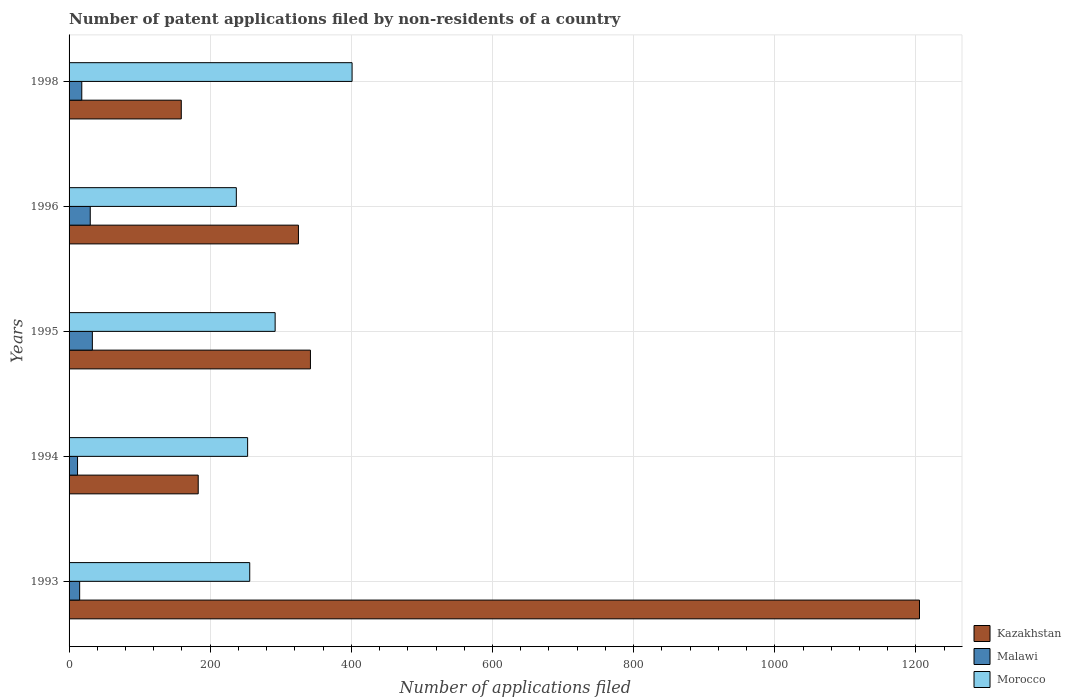Are the number of bars per tick equal to the number of legend labels?
Your answer should be compact. Yes. Are the number of bars on each tick of the Y-axis equal?
Offer a terse response. Yes. How many bars are there on the 4th tick from the top?
Make the answer very short. 3. How many bars are there on the 3rd tick from the bottom?
Give a very brief answer. 3. In how many cases, is the number of bars for a given year not equal to the number of legend labels?
Provide a short and direct response. 0. What is the number of applications filed in Morocco in 1993?
Provide a short and direct response. 256. Across all years, what is the maximum number of applications filed in Morocco?
Provide a succinct answer. 401. Across all years, what is the minimum number of applications filed in Malawi?
Your response must be concise. 12. What is the total number of applications filed in Morocco in the graph?
Give a very brief answer. 1439. What is the difference between the number of applications filed in Morocco in 1995 and that in 1998?
Your answer should be very brief. -109. What is the difference between the number of applications filed in Malawi in 1994 and the number of applications filed in Kazakhstan in 1996?
Provide a short and direct response. -313. What is the average number of applications filed in Malawi per year?
Provide a succinct answer. 21.6. What is the ratio of the number of applications filed in Malawi in 1995 to that in 1996?
Your answer should be compact. 1.1. What is the difference between the highest and the second highest number of applications filed in Morocco?
Ensure brevity in your answer.  109. What is the difference between the highest and the lowest number of applications filed in Kazakhstan?
Give a very brief answer. 1046. Is the sum of the number of applications filed in Kazakhstan in 1995 and 1996 greater than the maximum number of applications filed in Morocco across all years?
Offer a terse response. Yes. What does the 1st bar from the top in 1994 represents?
Provide a short and direct response. Morocco. What does the 3rd bar from the bottom in 1994 represents?
Give a very brief answer. Morocco. Are all the bars in the graph horizontal?
Offer a terse response. Yes. How many years are there in the graph?
Keep it short and to the point. 5. What is the difference between two consecutive major ticks on the X-axis?
Your response must be concise. 200. Does the graph contain grids?
Offer a terse response. Yes. How are the legend labels stacked?
Your answer should be very brief. Vertical. What is the title of the graph?
Offer a terse response. Number of patent applications filed by non-residents of a country. What is the label or title of the X-axis?
Provide a short and direct response. Number of applications filed. What is the label or title of the Y-axis?
Your answer should be compact. Years. What is the Number of applications filed in Kazakhstan in 1993?
Provide a succinct answer. 1205. What is the Number of applications filed in Malawi in 1993?
Give a very brief answer. 15. What is the Number of applications filed in Morocco in 1993?
Make the answer very short. 256. What is the Number of applications filed of Kazakhstan in 1994?
Offer a terse response. 183. What is the Number of applications filed of Morocco in 1994?
Your answer should be compact. 253. What is the Number of applications filed of Kazakhstan in 1995?
Give a very brief answer. 342. What is the Number of applications filed of Malawi in 1995?
Ensure brevity in your answer.  33. What is the Number of applications filed in Morocco in 1995?
Provide a succinct answer. 292. What is the Number of applications filed of Kazakhstan in 1996?
Ensure brevity in your answer.  325. What is the Number of applications filed in Malawi in 1996?
Your response must be concise. 30. What is the Number of applications filed in Morocco in 1996?
Your answer should be compact. 237. What is the Number of applications filed of Kazakhstan in 1998?
Provide a short and direct response. 159. What is the Number of applications filed in Morocco in 1998?
Your response must be concise. 401. Across all years, what is the maximum Number of applications filed in Kazakhstan?
Your answer should be compact. 1205. Across all years, what is the maximum Number of applications filed in Malawi?
Ensure brevity in your answer.  33. Across all years, what is the maximum Number of applications filed in Morocco?
Offer a terse response. 401. Across all years, what is the minimum Number of applications filed in Kazakhstan?
Make the answer very short. 159. Across all years, what is the minimum Number of applications filed of Malawi?
Provide a succinct answer. 12. Across all years, what is the minimum Number of applications filed of Morocco?
Provide a short and direct response. 237. What is the total Number of applications filed in Kazakhstan in the graph?
Provide a succinct answer. 2214. What is the total Number of applications filed in Malawi in the graph?
Make the answer very short. 108. What is the total Number of applications filed of Morocco in the graph?
Keep it short and to the point. 1439. What is the difference between the Number of applications filed of Kazakhstan in 1993 and that in 1994?
Provide a succinct answer. 1022. What is the difference between the Number of applications filed in Morocco in 1993 and that in 1994?
Your answer should be very brief. 3. What is the difference between the Number of applications filed in Kazakhstan in 1993 and that in 1995?
Make the answer very short. 863. What is the difference between the Number of applications filed of Morocco in 1993 and that in 1995?
Your answer should be compact. -36. What is the difference between the Number of applications filed in Kazakhstan in 1993 and that in 1996?
Give a very brief answer. 880. What is the difference between the Number of applications filed of Morocco in 1993 and that in 1996?
Keep it short and to the point. 19. What is the difference between the Number of applications filed of Kazakhstan in 1993 and that in 1998?
Provide a short and direct response. 1046. What is the difference between the Number of applications filed in Malawi in 1993 and that in 1998?
Your response must be concise. -3. What is the difference between the Number of applications filed in Morocco in 1993 and that in 1998?
Make the answer very short. -145. What is the difference between the Number of applications filed in Kazakhstan in 1994 and that in 1995?
Your answer should be compact. -159. What is the difference between the Number of applications filed of Morocco in 1994 and that in 1995?
Offer a terse response. -39. What is the difference between the Number of applications filed in Kazakhstan in 1994 and that in 1996?
Your answer should be very brief. -142. What is the difference between the Number of applications filed in Malawi in 1994 and that in 1996?
Make the answer very short. -18. What is the difference between the Number of applications filed of Kazakhstan in 1994 and that in 1998?
Your response must be concise. 24. What is the difference between the Number of applications filed of Malawi in 1994 and that in 1998?
Offer a very short reply. -6. What is the difference between the Number of applications filed in Morocco in 1994 and that in 1998?
Offer a terse response. -148. What is the difference between the Number of applications filed in Morocco in 1995 and that in 1996?
Keep it short and to the point. 55. What is the difference between the Number of applications filed in Kazakhstan in 1995 and that in 1998?
Offer a very short reply. 183. What is the difference between the Number of applications filed in Morocco in 1995 and that in 1998?
Your response must be concise. -109. What is the difference between the Number of applications filed of Kazakhstan in 1996 and that in 1998?
Keep it short and to the point. 166. What is the difference between the Number of applications filed of Malawi in 1996 and that in 1998?
Ensure brevity in your answer.  12. What is the difference between the Number of applications filed of Morocco in 1996 and that in 1998?
Ensure brevity in your answer.  -164. What is the difference between the Number of applications filed of Kazakhstan in 1993 and the Number of applications filed of Malawi in 1994?
Your response must be concise. 1193. What is the difference between the Number of applications filed in Kazakhstan in 1993 and the Number of applications filed in Morocco in 1994?
Ensure brevity in your answer.  952. What is the difference between the Number of applications filed in Malawi in 1993 and the Number of applications filed in Morocco in 1994?
Your response must be concise. -238. What is the difference between the Number of applications filed of Kazakhstan in 1993 and the Number of applications filed of Malawi in 1995?
Provide a succinct answer. 1172. What is the difference between the Number of applications filed in Kazakhstan in 1993 and the Number of applications filed in Morocco in 1995?
Provide a short and direct response. 913. What is the difference between the Number of applications filed in Malawi in 1993 and the Number of applications filed in Morocco in 1995?
Make the answer very short. -277. What is the difference between the Number of applications filed in Kazakhstan in 1993 and the Number of applications filed in Malawi in 1996?
Make the answer very short. 1175. What is the difference between the Number of applications filed in Kazakhstan in 1993 and the Number of applications filed in Morocco in 1996?
Make the answer very short. 968. What is the difference between the Number of applications filed in Malawi in 1993 and the Number of applications filed in Morocco in 1996?
Provide a short and direct response. -222. What is the difference between the Number of applications filed in Kazakhstan in 1993 and the Number of applications filed in Malawi in 1998?
Your answer should be very brief. 1187. What is the difference between the Number of applications filed in Kazakhstan in 1993 and the Number of applications filed in Morocco in 1998?
Offer a terse response. 804. What is the difference between the Number of applications filed in Malawi in 1993 and the Number of applications filed in Morocco in 1998?
Your answer should be very brief. -386. What is the difference between the Number of applications filed in Kazakhstan in 1994 and the Number of applications filed in Malawi in 1995?
Make the answer very short. 150. What is the difference between the Number of applications filed in Kazakhstan in 1994 and the Number of applications filed in Morocco in 1995?
Provide a short and direct response. -109. What is the difference between the Number of applications filed of Malawi in 1994 and the Number of applications filed of Morocco in 1995?
Your answer should be compact. -280. What is the difference between the Number of applications filed of Kazakhstan in 1994 and the Number of applications filed of Malawi in 1996?
Provide a succinct answer. 153. What is the difference between the Number of applications filed in Kazakhstan in 1994 and the Number of applications filed in Morocco in 1996?
Make the answer very short. -54. What is the difference between the Number of applications filed of Malawi in 1994 and the Number of applications filed of Morocco in 1996?
Offer a very short reply. -225. What is the difference between the Number of applications filed in Kazakhstan in 1994 and the Number of applications filed in Malawi in 1998?
Your answer should be very brief. 165. What is the difference between the Number of applications filed in Kazakhstan in 1994 and the Number of applications filed in Morocco in 1998?
Your answer should be very brief. -218. What is the difference between the Number of applications filed in Malawi in 1994 and the Number of applications filed in Morocco in 1998?
Your response must be concise. -389. What is the difference between the Number of applications filed of Kazakhstan in 1995 and the Number of applications filed of Malawi in 1996?
Provide a short and direct response. 312. What is the difference between the Number of applications filed of Kazakhstan in 1995 and the Number of applications filed of Morocco in 1996?
Provide a succinct answer. 105. What is the difference between the Number of applications filed of Malawi in 1995 and the Number of applications filed of Morocco in 1996?
Your answer should be very brief. -204. What is the difference between the Number of applications filed in Kazakhstan in 1995 and the Number of applications filed in Malawi in 1998?
Offer a very short reply. 324. What is the difference between the Number of applications filed of Kazakhstan in 1995 and the Number of applications filed of Morocco in 1998?
Provide a short and direct response. -59. What is the difference between the Number of applications filed in Malawi in 1995 and the Number of applications filed in Morocco in 1998?
Offer a very short reply. -368. What is the difference between the Number of applications filed in Kazakhstan in 1996 and the Number of applications filed in Malawi in 1998?
Make the answer very short. 307. What is the difference between the Number of applications filed in Kazakhstan in 1996 and the Number of applications filed in Morocco in 1998?
Give a very brief answer. -76. What is the difference between the Number of applications filed of Malawi in 1996 and the Number of applications filed of Morocco in 1998?
Your answer should be very brief. -371. What is the average Number of applications filed in Kazakhstan per year?
Ensure brevity in your answer.  442.8. What is the average Number of applications filed in Malawi per year?
Your answer should be very brief. 21.6. What is the average Number of applications filed in Morocco per year?
Your response must be concise. 287.8. In the year 1993, what is the difference between the Number of applications filed of Kazakhstan and Number of applications filed of Malawi?
Your answer should be very brief. 1190. In the year 1993, what is the difference between the Number of applications filed of Kazakhstan and Number of applications filed of Morocco?
Give a very brief answer. 949. In the year 1993, what is the difference between the Number of applications filed in Malawi and Number of applications filed in Morocco?
Keep it short and to the point. -241. In the year 1994, what is the difference between the Number of applications filed in Kazakhstan and Number of applications filed in Malawi?
Make the answer very short. 171. In the year 1994, what is the difference between the Number of applications filed in Kazakhstan and Number of applications filed in Morocco?
Provide a short and direct response. -70. In the year 1994, what is the difference between the Number of applications filed of Malawi and Number of applications filed of Morocco?
Your response must be concise. -241. In the year 1995, what is the difference between the Number of applications filed in Kazakhstan and Number of applications filed in Malawi?
Your answer should be compact. 309. In the year 1995, what is the difference between the Number of applications filed of Kazakhstan and Number of applications filed of Morocco?
Keep it short and to the point. 50. In the year 1995, what is the difference between the Number of applications filed of Malawi and Number of applications filed of Morocco?
Provide a short and direct response. -259. In the year 1996, what is the difference between the Number of applications filed of Kazakhstan and Number of applications filed of Malawi?
Provide a short and direct response. 295. In the year 1996, what is the difference between the Number of applications filed in Kazakhstan and Number of applications filed in Morocco?
Provide a succinct answer. 88. In the year 1996, what is the difference between the Number of applications filed of Malawi and Number of applications filed of Morocco?
Your response must be concise. -207. In the year 1998, what is the difference between the Number of applications filed of Kazakhstan and Number of applications filed of Malawi?
Give a very brief answer. 141. In the year 1998, what is the difference between the Number of applications filed in Kazakhstan and Number of applications filed in Morocco?
Give a very brief answer. -242. In the year 1998, what is the difference between the Number of applications filed of Malawi and Number of applications filed of Morocco?
Give a very brief answer. -383. What is the ratio of the Number of applications filed of Kazakhstan in 1993 to that in 1994?
Your answer should be compact. 6.58. What is the ratio of the Number of applications filed of Morocco in 1993 to that in 1994?
Keep it short and to the point. 1.01. What is the ratio of the Number of applications filed of Kazakhstan in 1993 to that in 1995?
Offer a very short reply. 3.52. What is the ratio of the Number of applications filed in Malawi in 1993 to that in 1995?
Offer a very short reply. 0.45. What is the ratio of the Number of applications filed of Morocco in 1993 to that in 1995?
Provide a succinct answer. 0.88. What is the ratio of the Number of applications filed of Kazakhstan in 1993 to that in 1996?
Provide a succinct answer. 3.71. What is the ratio of the Number of applications filed in Malawi in 1993 to that in 1996?
Offer a terse response. 0.5. What is the ratio of the Number of applications filed of Morocco in 1993 to that in 1996?
Give a very brief answer. 1.08. What is the ratio of the Number of applications filed in Kazakhstan in 1993 to that in 1998?
Make the answer very short. 7.58. What is the ratio of the Number of applications filed in Malawi in 1993 to that in 1998?
Your answer should be compact. 0.83. What is the ratio of the Number of applications filed of Morocco in 1993 to that in 1998?
Your answer should be compact. 0.64. What is the ratio of the Number of applications filed of Kazakhstan in 1994 to that in 1995?
Provide a succinct answer. 0.54. What is the ratio of the Number of applications filed of Malawi in 1994 to that in 1995?
Your response must be concise. 0.36. What is the ratio of the Number of applications filed of Morocco in 1994 to that in 1995?
Ensure brevity in your answer.  0.87. What is the ratio of the Number of applications filed of Kazakhstan in 1994 to that in 1996?
Offer a terse response. 0.56. What is the ratio of the Number of applications filed in Malawi in 1994 to that in 1996?
Your response must be concise. 0.4. What is the ratio of the Number of applications filed of Morocco in 1994 to that in 1996?
Offer a very short reply. 1.07. What is the ratio of the Number of applications filed of Kazakhstan in 1994 to that in 1998?
Offer a terse response. 1.15. What is the ratio of the Number of applications filed of Morocco in 1994 to that in 1998?
Offer a very short reply. 0.63. What is the ratio of the Number of applications filed of Kazakhstan in 1995 to that in 1996?
Your answer should be compact. 1.05. What is the ratio of the Number of applications filed in Malawi in 1995 to that in 1996?
Your answer should be compact. 1.1. What is the ratio of the Number of applications filed in Morocco in 1995 to that in 1996?
Provide a succinct answer. 1.23. What is the ratio of the Number of applications filed in Kazakhstan in 1995 to that in 1998?
Your answer should be compact. 2.15. What is the ratio of the Number of applications filed of Malawi in 1995 to that in 1998?
Give a very brief answer. 1.83. What is the ratio of the Number of applications filed of Morocco in 1995 to that in 1998?
Keep it short and to the point. 0.73. What is the ratio of the Number of applications filed in Kazakhstan in 1996 to that in 1998?
Your answer should be compact. 2.04. What is the ratio of the Number of applications filed in Malawi in 1996 to that in 1998?
Your answer should be compact. 1.67. What is the ratio of the Number of applications filed in Morocco in 1996 to that in 1998?
Your answer should be compact. 0.59. What is the difference between the highest and the second highest Number of applications filed in Kazakhstan?
Provide a short and direct response. 863. What is the difference between the highest and the second highest Number of applications filed in Morocco?
Offer a very short reply. 109. What is the difference between the highest and the lowest Number of applications filed in Kazakhstan?
Give a very brief answer. 1046. What is the difference between the highest and the lowest Number of applications filed in Morocco?
Keep it short and to the point. 164. 